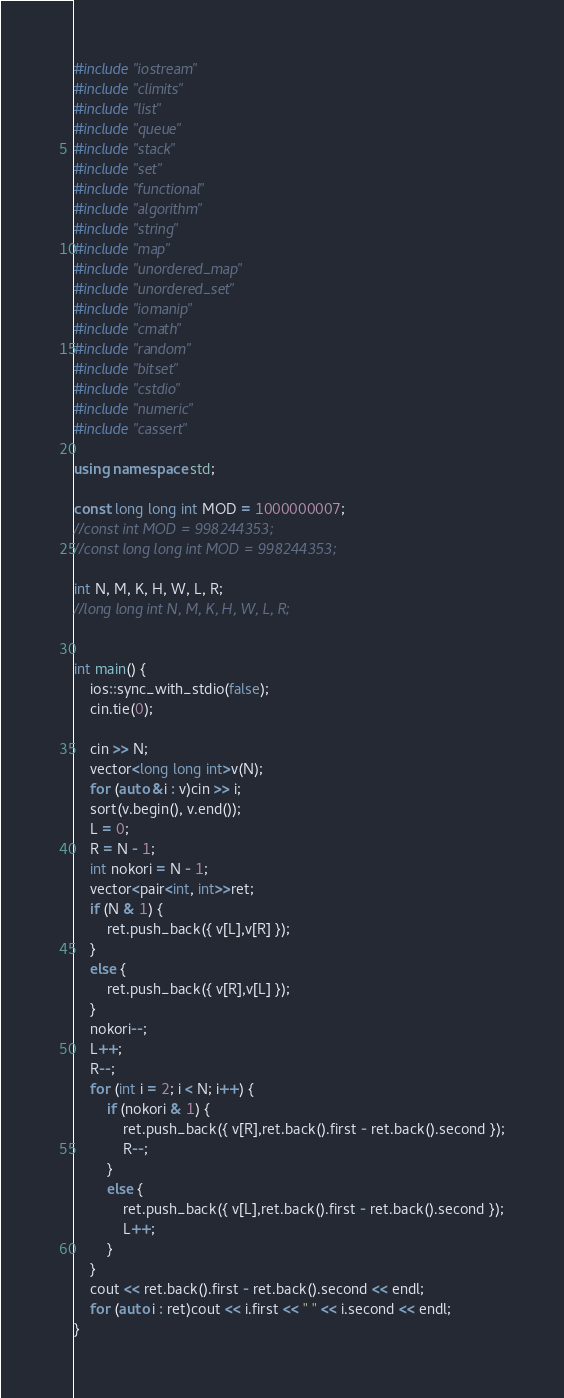<code> <loc_0><loc_0><loc_500><loc_500><_C++_>#include "iostream"
#include "climits"
#include "list"
#include "queue"
#include "stack"
#include "set"
#include "functional"
#include "algorithm"
#include "string"
#include "map"
#include "unordered_map"
#include "unordered_set"
#include "iomanip"
#include "cmath"
#include "random"
#include "bitset"
#include "cstdio"
#include "numeric"
#include "cassert"

using namespace std;

const long long int MOD = 1000000007;
//const int MOD = 998244353;
//const long long int MOD = 998244353;

int N, M, K, H, W, L, R;
//long long int N, M, K, H, W, L, R;


int main() {
	ios::sync_with_stdio(false);
	cin.tie(0);

	cin >> N;
	vector<long long int>v(N);
	for (auto &i : v)cin >> i;
	sort(v.begin(), v.end());
	L = 0;
	R = N - 1;
	int nokori = N - 1;
	vector<pair<int, int>>ret;
	if (N & 1) {
		ret.push_back({ v[L],v[R] });
	}
	else {
		ret.push_back({ v[R],v[L] });
	}
	nokori--;
	L++;
	R--;
	for (int i = 2; i < N; i++) {
		if (nokori & 1) {
			ret.push_back({ v[R],ret.back().first - ret.back().second });
			R--;
		}
		else {
			ret.push_back({ v[L],ret.back().first - ret.back().second });
			L++;
		}
	}
	cout << ret.back().first - ret.back().second << endl;
	for (auto i : ret)cout << i.first << " " << i.second << endl;
}</code> 